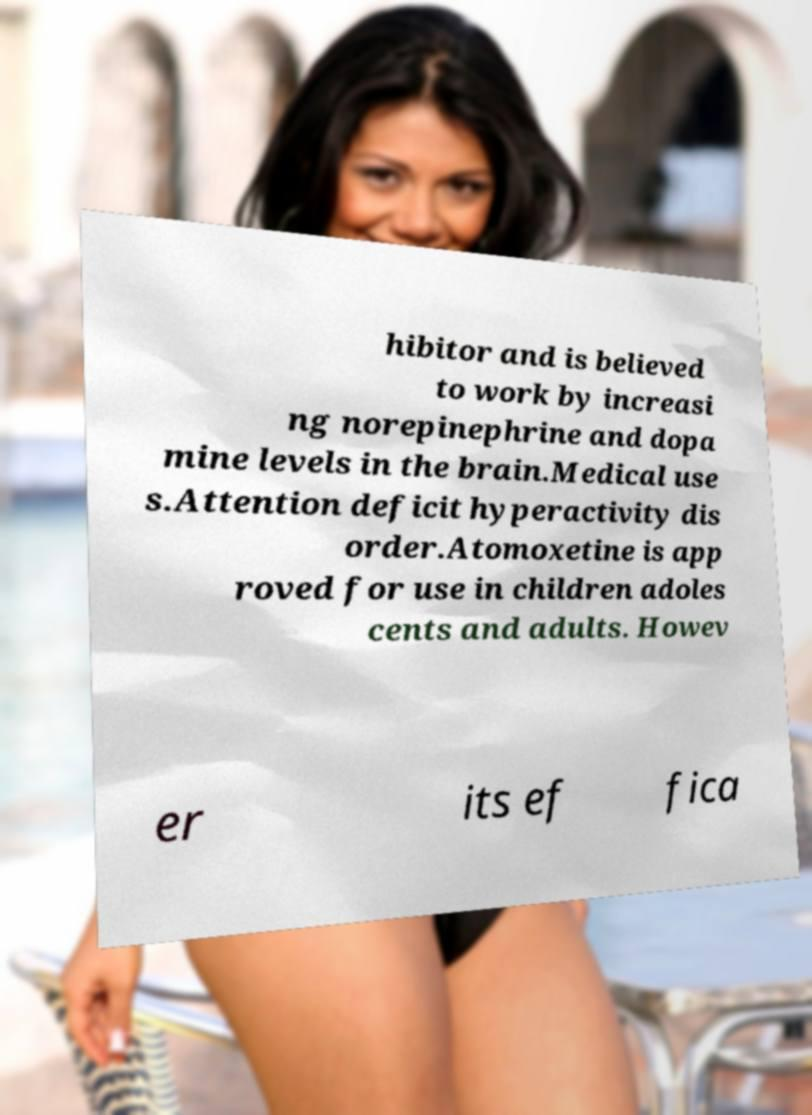Could you extract and type out the text from this image? hibitor and is believed to work by increasi ng norepinephrine and dopa mine levels in the brain.Medical use s.Attention deficit hyperactivity dis order.Atomoxetine is app roved for use in children adoles cents and adults. Howev er its ef fica 